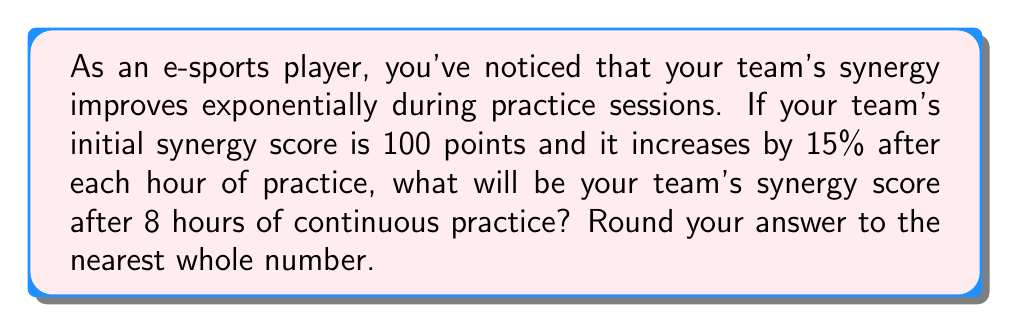Help me with this question. Let's approach this step-by-step:

1) The initial synergy score is 100 points.

2) The increase is 15% (or 0.15) per hour.

3) We can represent this as an exponential growth function:
   $$ S = 100 \cdot (1 + 0.15)^t $$
   Where S is the synergy score and t is the number of hours.

4) We need to calculate this for t = 8 hours:
   $$ S = 100 \cdot (1.15)^8 $$

5) Let's solve this:
   $$ S = 100 \cdot 3.0590 $$
   $$ S = 305.90 $$

6) Rounding to the nearest whole number:
   $$ S \approx 306 $$

This exponential growth model shows how small, consistent improvements can lead to significant gains over time, much like how repeated practice sessions can dramatically improve team performance in e-sports.
Answer: 306 